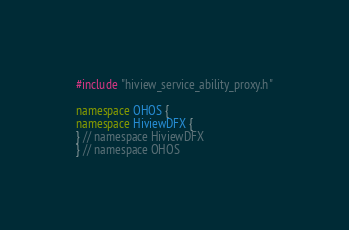<code> <loc_0><loc_0><loc_500><loc_500><_C++_>#include "hiview_service_ability_proxy.h"

namespace OHOS {
namespace HiviewDFX {
} // namespace HiviewDFX
} // namespace OHOS
</code> 